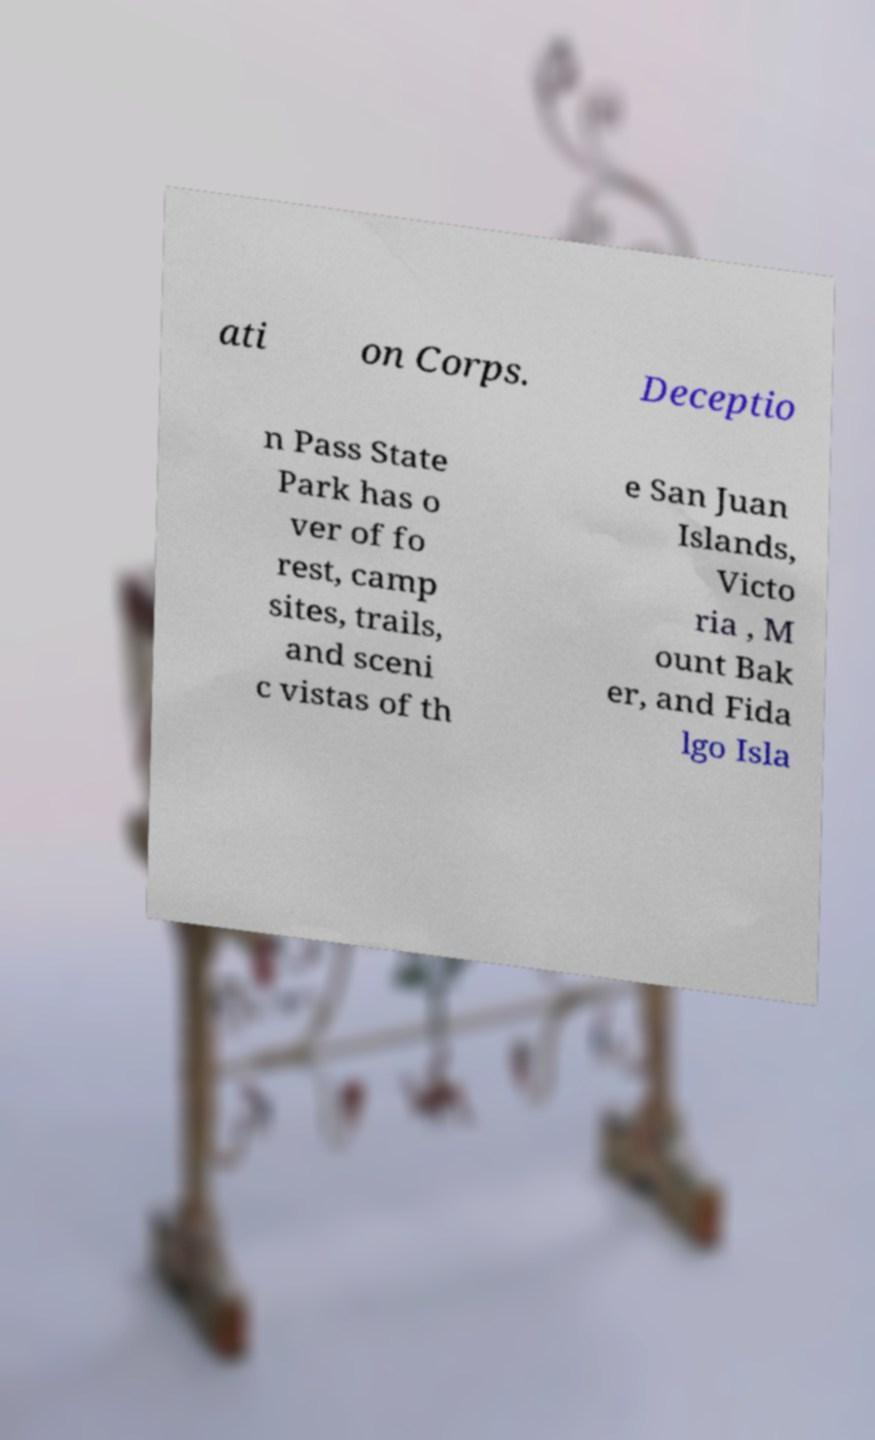There's text embedded in this image that I need extracted. Can you transcribe it verbatim? ati on Corps. Deceptio n Pass State Park has o ver of fo rest, camp sites, trails, and sceni c vistas of th e San Juan Islands, Victo ria , M ount Bak er, and Fida lgo Isla 